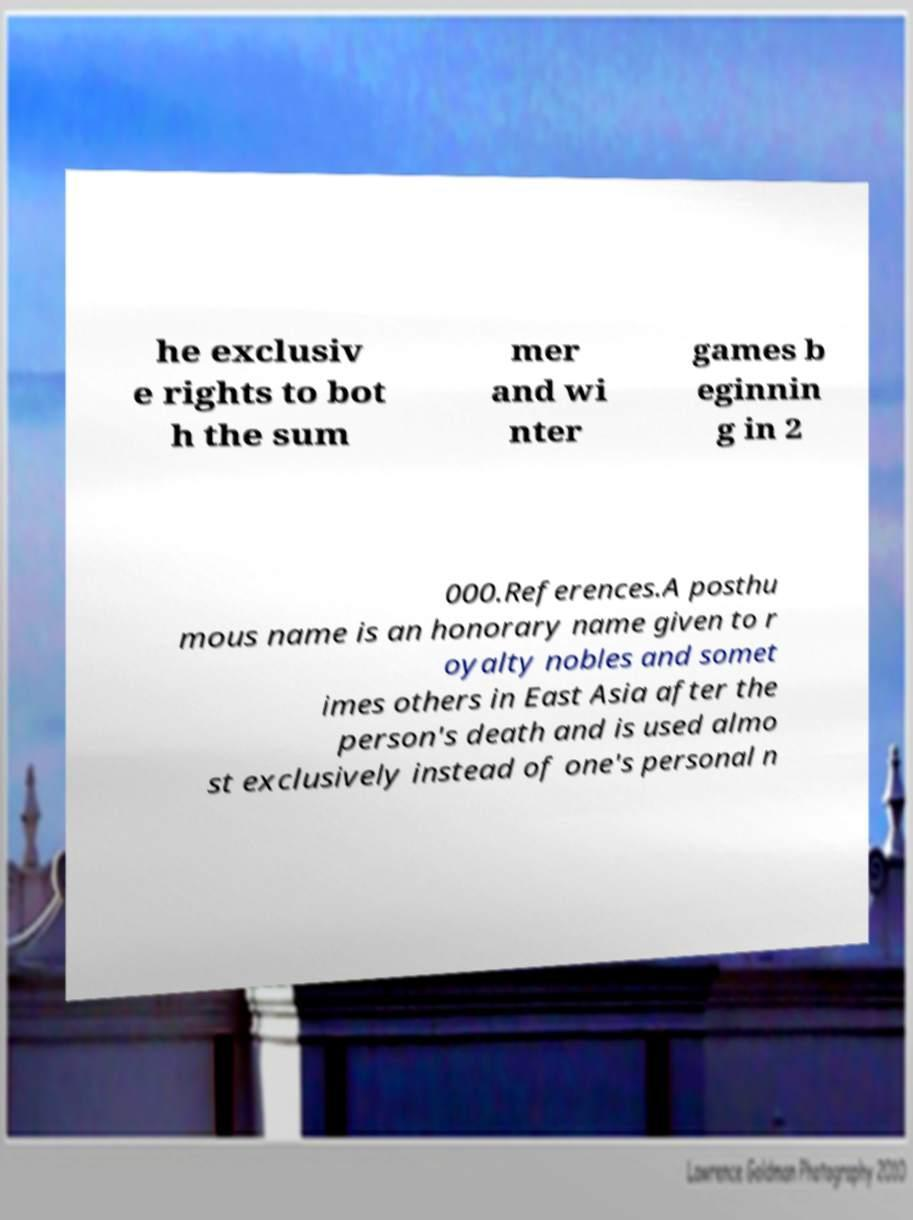Could you extract and type out the text from this image? he exclusiv e rights to bot h the sum mer and wi nter games b eginnin g in 2 000.References.A posthu mous name is an honorary name given to r oyalty nobles and somet imes others in East Asia after the person's death and is used almo st exclusively instead of one's personal n 